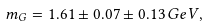<formula> <loc_0><loc_0><loc_500><loc_500>m _ { G } = 1 . 6 1 \pm 0 . 0 7 \pm 0 . 1 3 \, G e V ,</formula> 